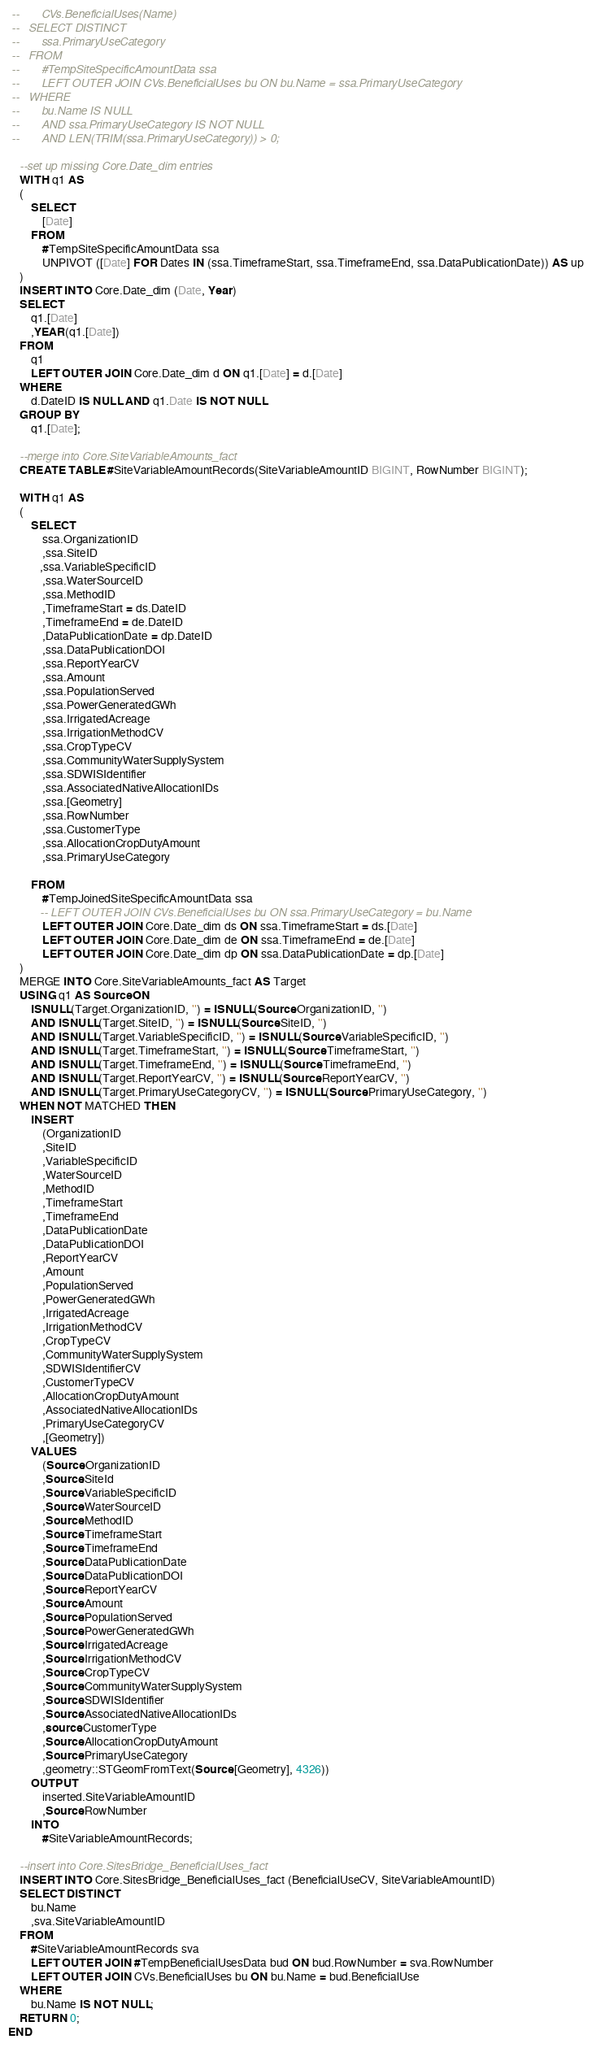Convert code to text. <code><loc_0><loc_0><loc_500><loc_500><_SQL_> --       CVs.BeneficialUses(Name)
 --   SELECT DISTINCT
 --       ssa.PrimaryUseCategory
 --   FROM
 --       #TempSiteSpecificAmountData ssa
 --       LEFT OUTER JOIN CVs.BeneficialUses bu ON bu.Name = ssa.PrimaryUseCategory
 --   WHERE
 --       bu.Name IS NULL
 --       AND ssa.PrimaryUseCategory IS NOT NULL
 --       AND LEN(TRIM(ssa.PrimaryUseCategory)) > 0;
    
    --set up missing Core.Date_dim entries
    WITH q1 AS
    (
        SELECT
            [Date]
        FROM
            #TempSiteSpecificAmountData ssa
            UNPIVOT ([Date] FOR Dates IN (ssa.TimeframeStart, ssa.TimeframeEnd, ssa.DataPublicationDate)) AS up
	)
    INSERT INTO Core.Date_dim (Date, Year)
    SELECT
        q1.[Date]
        ,YEAR(q1.[Date])
    FROM
        q1
        LEFT OUTER JOIN Core.Date_dim d ON q1.[Date] = d.[Date]
    WHERE
        d.DateID IS NULL AND q1.Date IS NOT NULL
    GROUP BY
        q1.[Date];
    
    --merge into Core.SiteVariableAmounts_fact
    CREATE TABLE #SiteVariableAmountRecords(SiteVariableAmountID BIGINT, RowNumber BIGINT);
    
    WITH q1 AS
    (
        SELECT
            ssa.OrganizationID
            ,ssa.SiteID
           ,ssa.VariableSpecificID
            ,ssa.WaterSourceID
            ,ssa.MethodID
			,TimeframeStart = ds.DateID
            ,TimeframeEnd = de.DateID
            ,DataPublicationDate = dp.DateID
			,ssa.DataPublicationDOI
            ,ssa.ReportYearCV
            ,ssa.Amount
            ,ssa.PopulationServed
            ,ssa.PowerGeneratedGWh
            ,ssa.IrrigatedAcreage
            ,ssa.IrrigationMethodCV
            ,ssa.CropTypeCV
			,ssa.CommunityWaterSupplySystem
			,ssa.SDWISIdentifier
            ,ssa.AssociatedNativeAllocationIDs
            ,ssa.[Geometry]
			,ssa.RowNumber
			,ssa.CustomerType
			,ssa.AllocationCropDutyAmount
			,ssa.PrimaryUseCategory
			
        FROM
            #TempJoinedSiteSpecificAmountData ssa
           -- LEFT OUTER JOIN CVs.BeneficialUses bu ON ssa.PrimaryUseCategory = bu.Name
            LEFT OUTER JOIN Core.Date_dim ds ON ssa.TimeframeStart = ds.[Date]
            LEFT OUTER JOIN Core.Date_dim de ON ssa.TimeframeEnd = de.[Date]
            LEFT OUTER JOIN Core.Date_dim dp ON ssa.DataPublicationDate = dp.[Date]
    )
    MERGE INTO Core.SiteVariableAmounts_fact AS Target
	USING q1 AS Source ON
		ISNULL(Target.OrganizationID, '') = ISNULL(Source.OrganizationID, '')
		AND ISNULL(Target.SiteID, '') = ISNULL(Source.SiteID, '')
		AND ISNULL(Target.VariableSpecificID, '') = ISNULL(Source.VariableSpecificID, '')
		AND ISNULL(Target.TimeframeStart, '') = ISNULL(Source.TimeframeStart, '')
		AND ISNULL(Target.TimeframeEnd, '') = ISNULL(Source.TimeframeEnd, '')
		AND ISNULL(Target.ReportYearCV, '') = ISNULL(Source.ReportYearCV, '')
		AND ISNULL(Target.PrimaryUseCategoryCV, '') = ISNULL(Source.PrimaryUseCategory, '')
	WHEN NOT MATCHED THEN
		INSERT
			(OrganizationID
			,SiteID
			,VariableSpecificID
			,WaterSourceID
			,MethodID
			,TimeframeStart
			,TimeframeEnd
			,DataPublicationDate
			,DataPublicationDOI
			,ReportYearCV
			,Amount
			,PopulationServed
			,PowerGeneratedGWh
			,IrrigatedAcreage
			,IrrigationMethodCV
			,CropTypeCV
			,CommunityWaterSupplySystem
			,SDWISIdentifierCV
			,CustomerTypeCV
			,AllocationCropDutyAmount
			,AssociatedNativeAllocationIDs
			,PrimaryUseCategoryCV
			,[Geometry])
		VALUES
			(Source.OrganizationID
			,Source.SiteId
			,Source.VariableSpecificID
			,Source.WaterSourceID
			,Source.MethodID
			,Source.TimeframeStart
			,Source.TimeframeEnd
			,Source.DataPublicationDate
			,Source.DataPublicationDOI
			,Source.ReportYearCV
			,Source.Amount
			,Source.PopulationServed
			,Source.PowerGeneratedGWh
			,Source.IrrigatedAcreage
			,Source.IrrigationMethodCV
			,Source.CropTypeCV
			,Source.CommunityWaterSupplySystem
			,Source.SDWISIdentifier
			,Source.AssociatedNativeAllocationIDs
			,source.CustomerType
			,Source.AllocationCropDutyAmount
			,Source.PrimaryUseCategory
			,geometry::STGeomFromText(Source.[Geometry], 4326))
		OUTPUT
			inserted.SiteVariableAmountID
			,Source.RowNumber
		INTO
			#SiteVariableAmountRecords;
    
    --insert into Core.SitesBridge_BeneficialUses_fact
	INSERT INTO Core.SitesBridge_BeneficialUses_fact (BeneficialUseCV, SiteVariableAmountID)
	SELECT DISTINCT
		bu.Name
		,sva.SiteVariableAmountID
	FROM
		#SiteVariableAmountRecords sva
		LEFT OUTER JOIN #TempBeneficialUsesData bud ON bud.RowNumber = sva.RowNumber
		LEFT OUTER JOIN CVs.BeneficialUses bu ON bu.Name = bud.BeneficialUse
	WHERE
		bu.Name IS NOT NULL;
	RETURN 0;
END</code> 